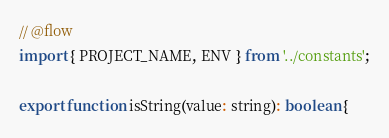Convert code to text. <code><loc_0><loc_0><loc_500><loc_500><_JavaScript_>// @flow
import { PROJECT_NAME, ENV } from '../constants';

export function isString(value: string): boolean {</code> 